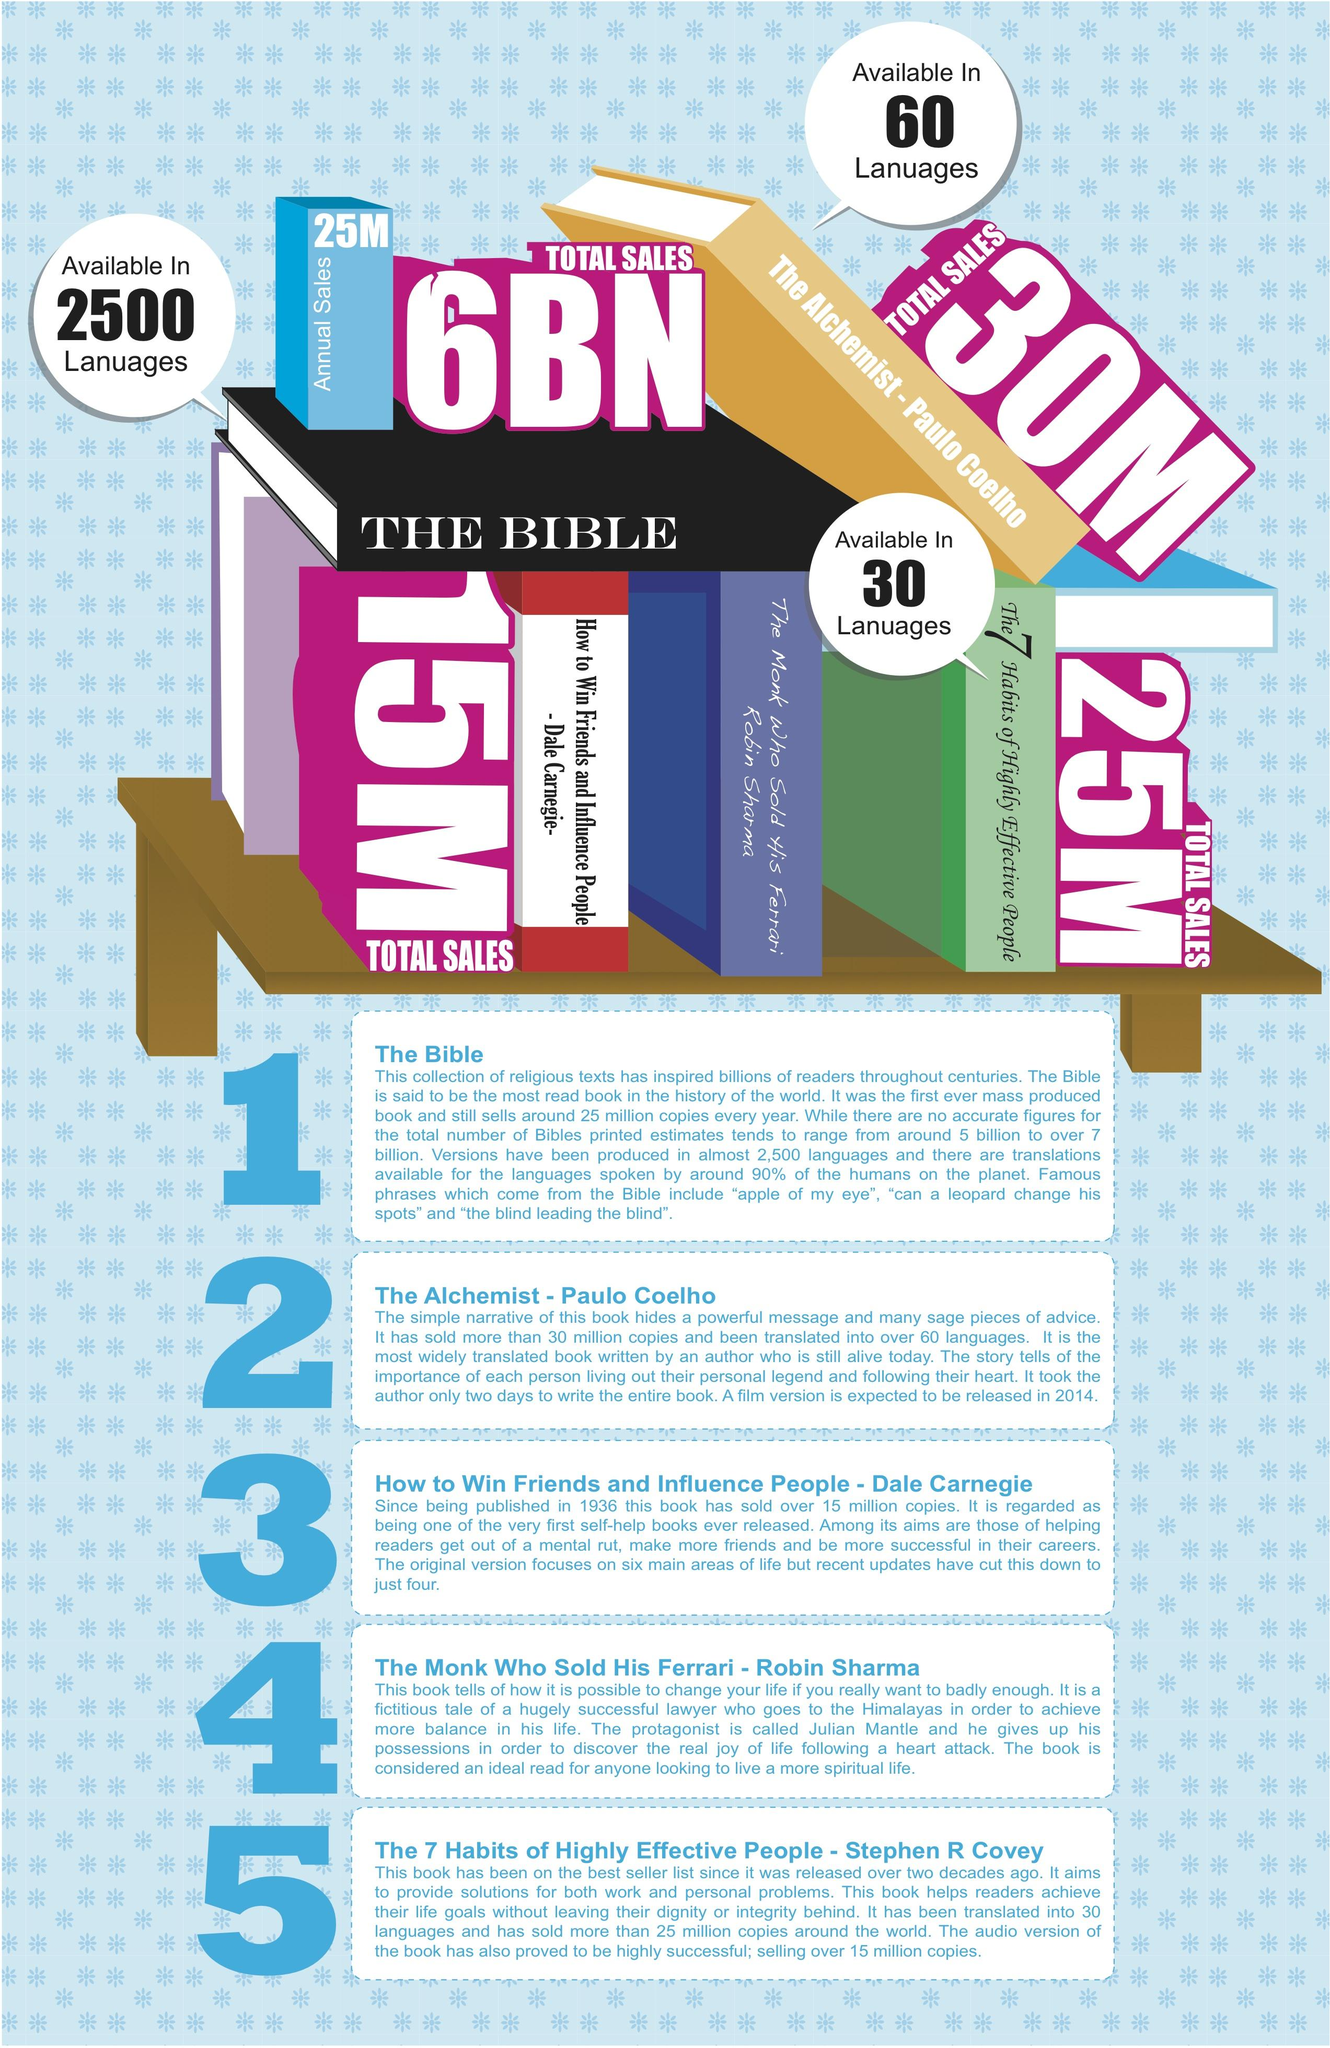Highlight a few significant elements in this photo. The Alchemist is currently available in 60 languages. 